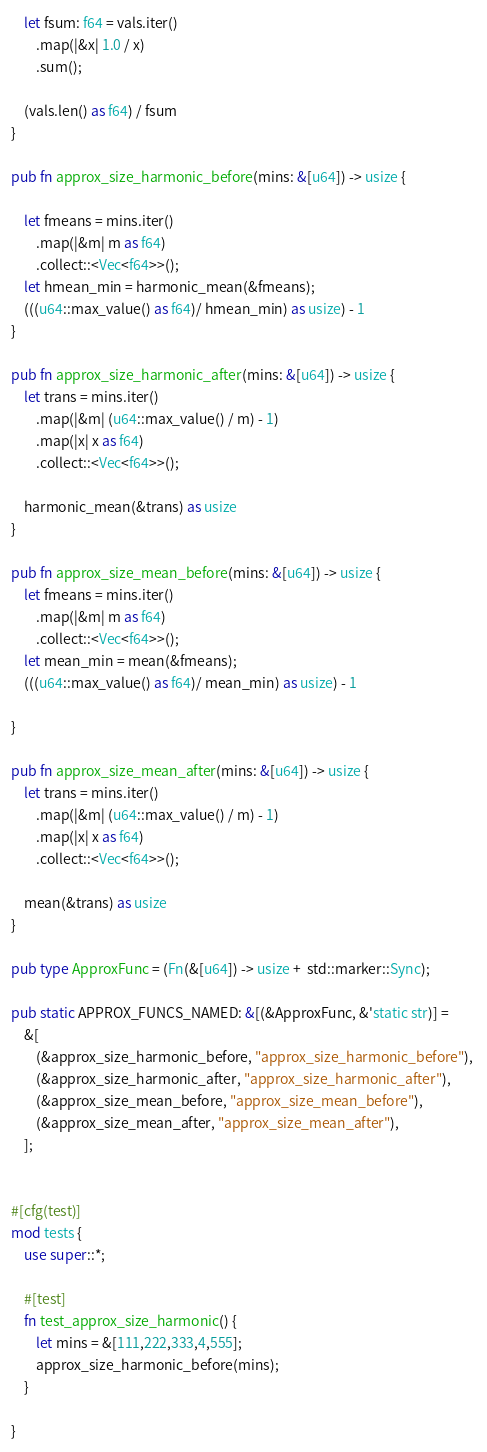Convert code to text. <code><loc_0><loc_0><loc_500><loc_500><_Rust_>    let fsum: f64 = vals.iter()
        .map(|&x| 1.0 / x)
        .sum();

    (vals.len() as f64) / fsum
}

pub fn approx_size_harmonic_before(mins: &[u64]) -> usize {

    let fmeans = mins.iter()
        .map(|&m| m as f64)
        .collect::<Vec<f64>>();
    let hmean_min = harmonic_mean(&fmeans);
    (((u64::max_value() as f64)/ hmean_min) as usize) - 1
}

pub fn approx_size_harmonic_after(mins: &[u64]) -> usize {
    let trans = mins.iter()
        .map(|&m| (u64::max_value() / m) - 1)
        .map(|x| x as f64)
        .collect::<Vec<f64>>();

    harmonic_mean(&trans) as usize
}

pub fn approx_size_mean_before(mins: &[u64]) -> usize {
    let fmeans = mins.iter()
        .map(|&m| m as f64)
        .collect::<Vec<f64>>();
    let mean_min = mean(&fmeans);
    (((u64::max_value() as f64)/ mean_min) as usize) - 1

}

pub fn approx_size_mean_after(mins: &[u64]) -> usize {
    let trans = mins.iter()
        .map(|&m| (u64::max_value() / m) - 1)
        .map(|x| x as f64)
        .collect::<Vec<f64>>();

    mean(&trans) as usize
}

pub type ApproxFunc = (Fn(&[u64]) -> usize +  std::marker::Sync);

pub static APPROX_FUNCS_NAMED: &[(&ApproxFunc, &'static str)] = 
    &[
        (&approx_size_harmonic_before, "approx_size_harmonic_before"), 
        (&approx_size_harmonic_after, "approx_size_harmonic_after"),
        (&approx_size_mean_before, "approx_size_mean_before"),
        (&approx_size_mean_after, "approx_size_mean_after"),
    ];


#[cfg(test)]
mod tests {
    use super::*;

    #[test]
    fn test_approx_size_harmonic() {
        let mins = &[111,222,333,4,555];
        approx_size_harmonic_before(mins);
    }

}
</code> 